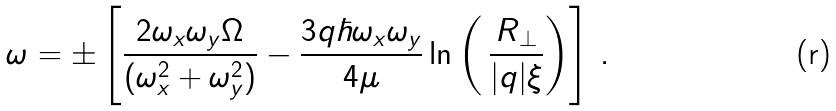<formula> <loc_0><loc_0><loc_500><loc_500>\omega = \pm \left [ \frac { 2 \omega _ { x } \omega _ { y } \Omega } { ( \omega _ { x } ^ { 2 } + \omega _ { y } ^ { 2 } ) } - \frac { 3 q \hbar { \omega } _ { x } \omega _ { y } } { 4 \mu } \ln \left ( \, \frac { R _ { \perp } } { | q | \xi } \right ) \right ] \, .</formula> 